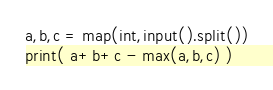<code> <loc_0><loc_0><loc_500><loc_500><_Python_>a,b,c = map(int,input().split())
print( a+b+c - max(a,b,c) )</code> 